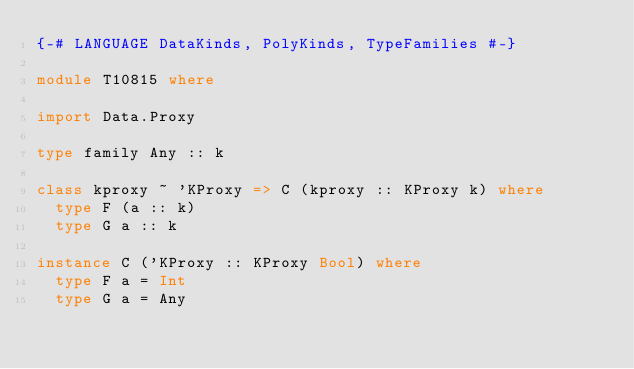<code> <loc_0><loc_0><loc_500><loc_500><_Haskell_>{-# LANGUAGE DataKinds, PolyKinds, TypeFamilies #-}

module T10815 where

import Data.Proxy

type family Any :: k

class kproxy ~ 'KProxy => C (kproxy :: KProxy k) where
  type F (a :: k)
  type G a :: k

instance C ('KProxy :: KProxy Bool) where
  type F a = Int
  type G a = Any
</code> 